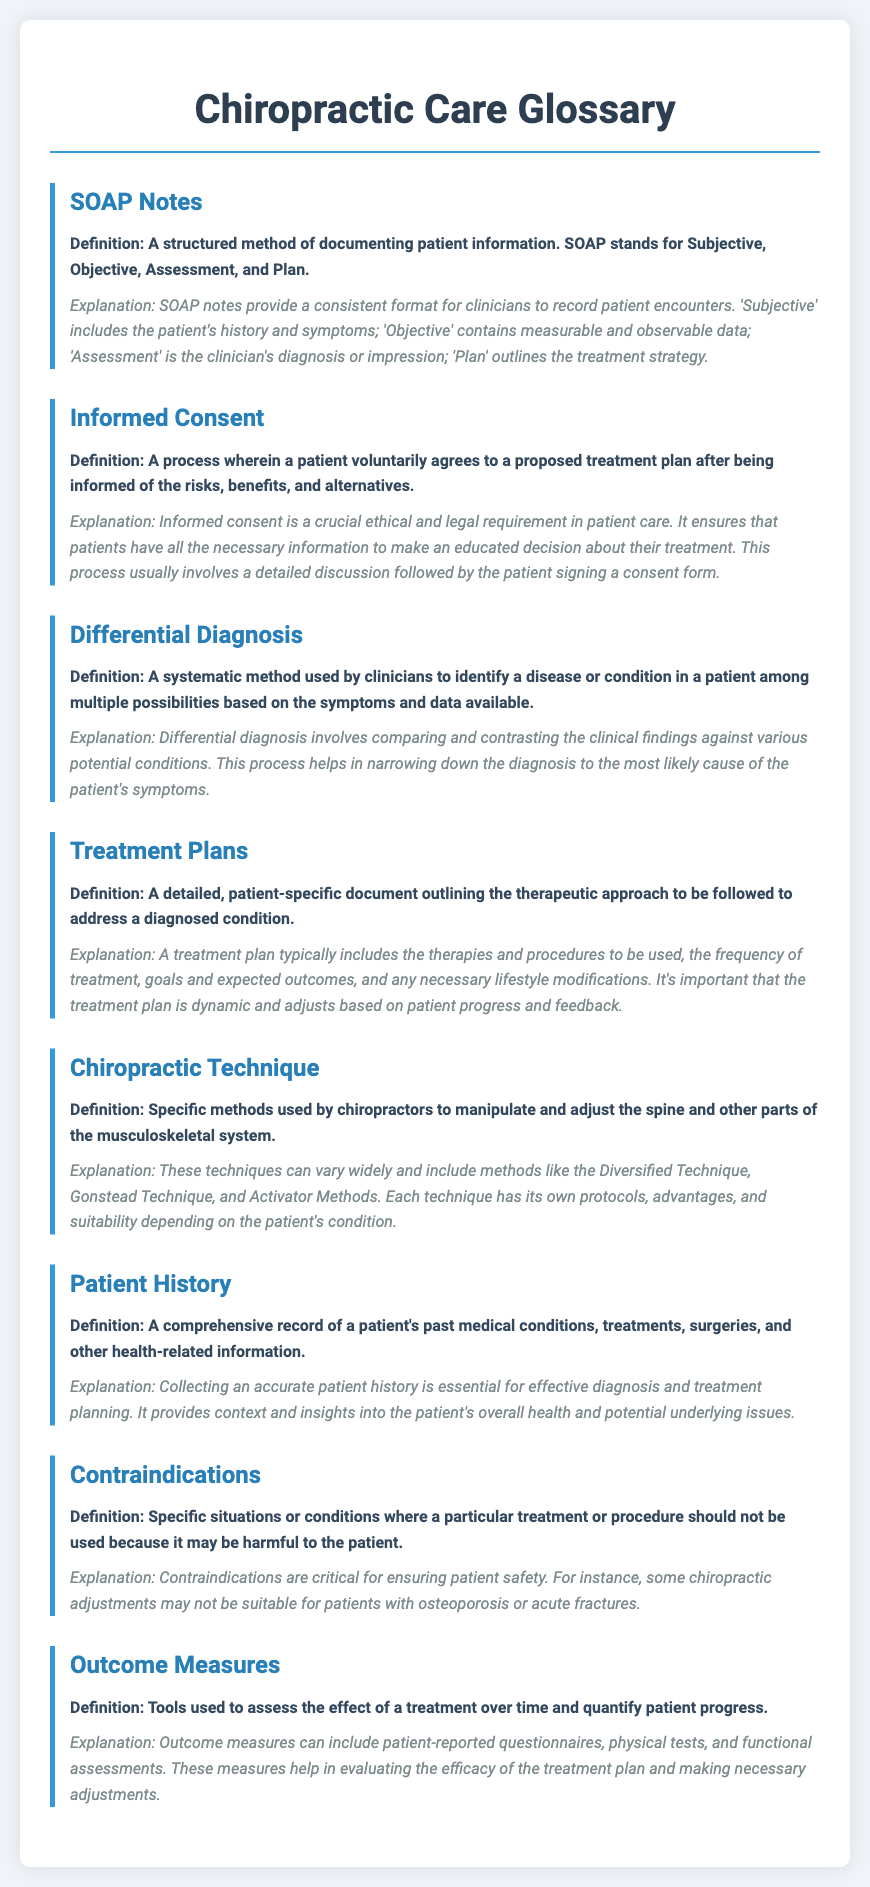What does SOAP stand for? The SOAP acronym stands for Subjective, Objective, Assessment, and Plan, which are the components of the SOAP notes format.
Answer: Subjective, Objective, Assessment, Plan What is the definition of Informed Consent? Informed Consent is defined as a process wherein a patient voluntarily agrees to a proposed treatment plan after being informed of the risks, benefits, and alternatives.
Answer: A process wherein a patient voluntarily agrees to a proposed treatment plan What is a Treatment Plan? A Treatment Plan is defined as a detailed, patient-specific document outlining the therapeutic approach to be followed to address a diagnosed condition.
Answer: A detailed, patient-specific document outlining the therapeutic approach What are Contraindications? Contraindications are defined as specific situations or conditions where a particular treatment or procedure should not be used because it may be harmful to the patient.
Answer: Specific situations or conditions where treatment should not be used What do Outcome Measures assess? Outcome Measures are used to assess the effect of a treatment over time and quantify patient progress.
Answer: The effect of treatment over time Explain the role of Patient History in chiropractic care. Patient History provides context and insights into the patient's overall health and potential underlying issues, essential for effective diagnosis and treatment planning.
Answer: Context and insights into overall health How does Differential Diagnosis help clinicians? Differential Diagnosis helps clinicians by comparing and contrasting clinical findings against various potential conditions to narrow down to the most likely cause of symptoms.
Answer: Narrow down to the most likely cause of symptoms What is the purpose of SOAP notes? SOAP notes provide a consistent format for clinicians to record patient encounters, ensuring thorough documentation.
Answer: A consistent format for documenting patient encounters 